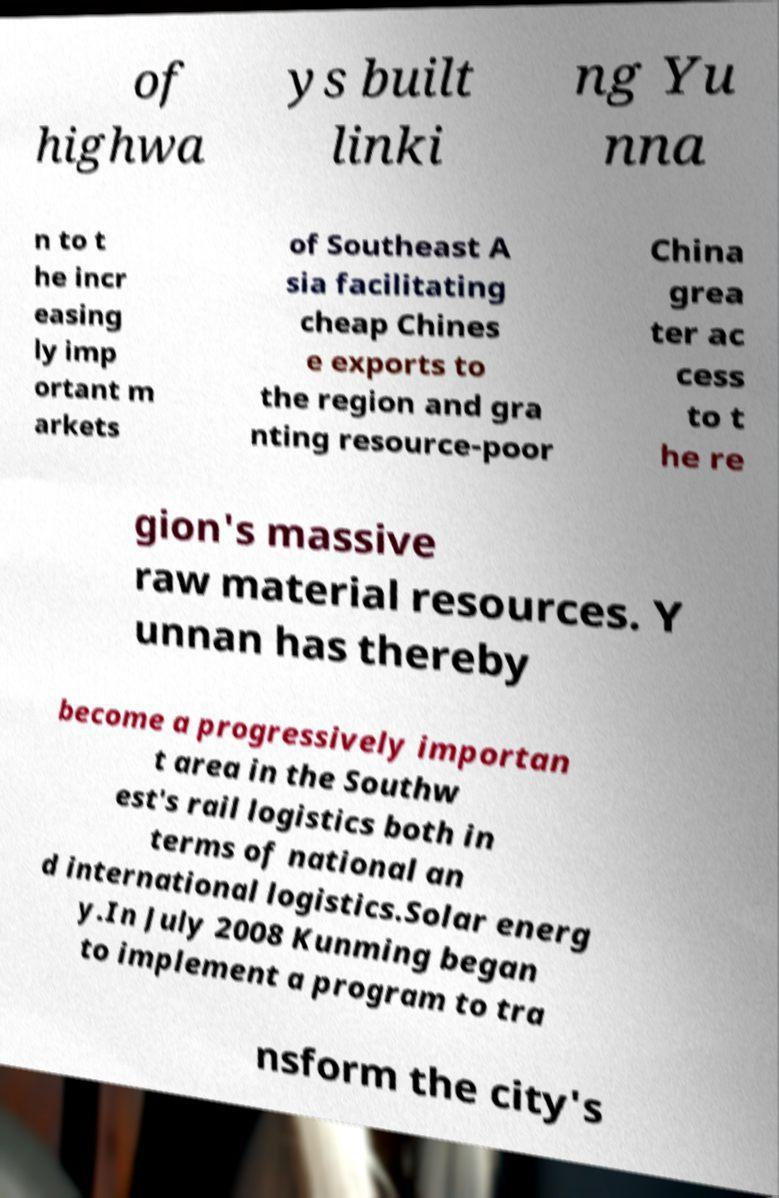Can you accurately transcribe the text from the provided image for me? of highwa ys built linki ng Yu nna n to t he incr easing ly imp ortant m arkets of Southeast A sia facilitating cheap Chines e exports to the region and gra nting resource-poor China grea ter ac cess to t he re gion's massive raw material resources. Y unnan has thereby become a progressively importan t area in the Southw est's rail logistics both in terms of national an d international logistics.Solar energ y.In July 2008 Kunming began to implement a program to tra nsform the city's 